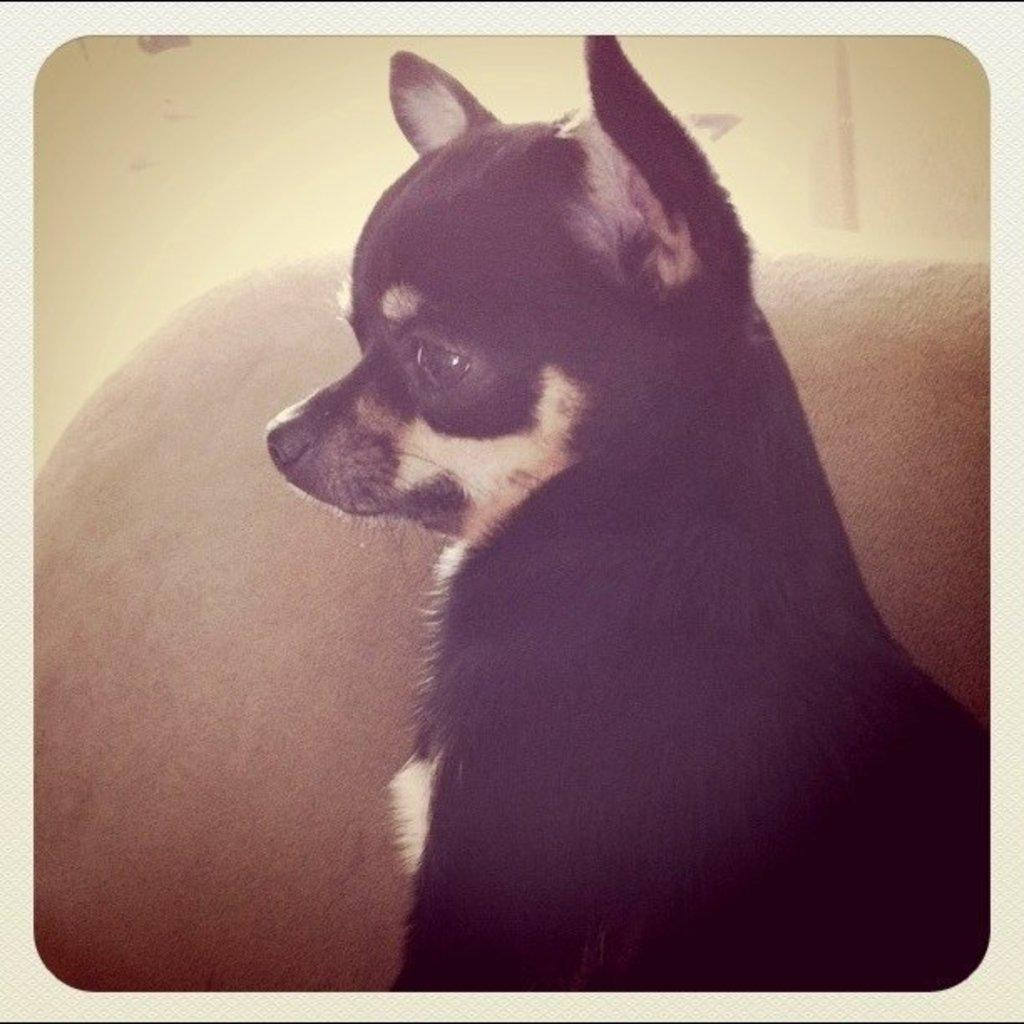What type of animal is in the image? There is a dog in the image. What is the color of the dog? The dog is black in color, with some white color near its face. What can be seen in the background of the image? There is a brown color substance and a wall visible in the background. What type of view can be seen from the dog's perspective in the image? The image does not provide a view from the dog's perspective, as it is a static image and does not show the dog's point of view. 